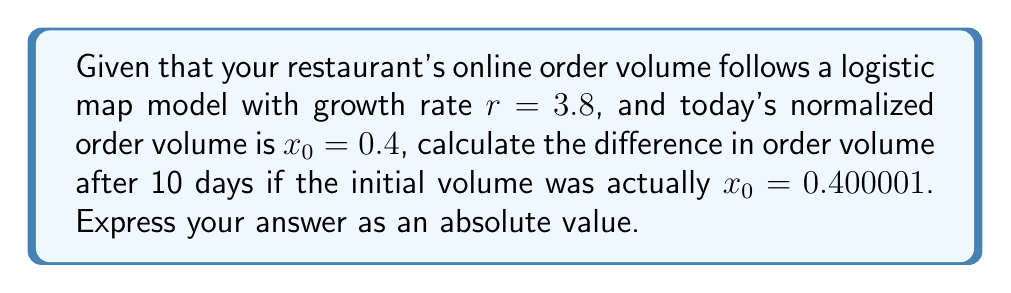Help me with this question. To solve this problem, we'll use the logistic map equation and iterate it 10 times for both initial conditions. Then we'll compare the results.

The logistic map equation is:

$$x_{n+1} = rx_n(1-x_n)$$

Where $r = 3.8$ and we have two initial conditions:
$x_0 = 0.4$ and $x_0 = 0.400001$

Let's iterate for both cases:

For $x_0 = 0.4$:
1. $x_1 = 3.8 * 0.4 * (1-0.4) = 0.912$
2. $x_2 = 3.8 * 0.912 * (1-0.912) = 0.305318976$
3. $x_3 = 3.8 * 0.305318976 * (1-0.305318976) = 0.805714262$
...
10. $x_{10} = 0.826308560$

For $x_0 = 0.400001$:
1. $x_1 = 3.8 * 0.400001 * (1-0.400001) = 0.912002280$
2. $x_2 = 3.8 * 0.912002280 * (1-0.912002280) = 0.305314169$
3. $x_3 = 3.8 * 0.305314169 * (1-0.305314169) = 0.805721936$
...
10. $x_{10} = 0.826312340$

The difference after 10 iterations is:
$|0.826308560 - 0.826312340| = 0.00000378$

This small difference in the 10th iteration, despite starting with nearly identical initial conditions, demonstrates the sensitivity to initial conditions characteristic of chaotic systems.
Answer: 0.00000378 